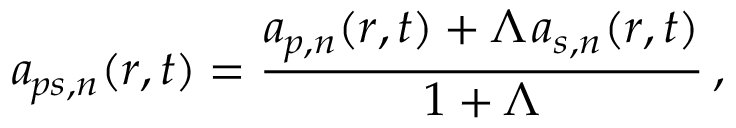Convert formula to latex. <formula><loc_0><loc_0><loc_500><loc_500>a _ { \, p s , n } ( r , t ) = \frac { a _ { \, p , n } ( r , t ) + \Lambda \, a _ { s , n } ( r , t ) } { 1 + \Lambda } \, ,</formula> 